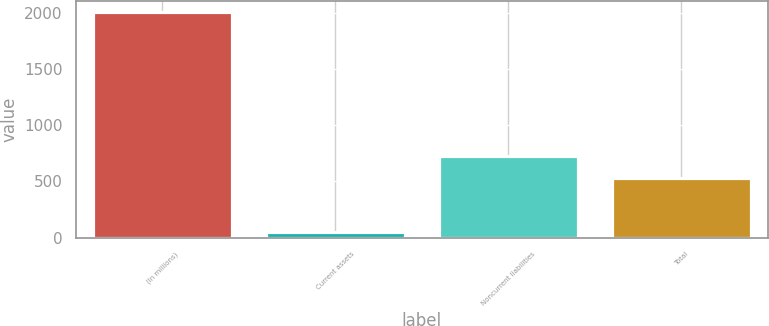<chart> <loc_0><loc_0><loc_500><loc_500><bar_chart><fcel>(In millions)<fcel>Current assets<fcel>Noncurrent liabilities<fcel>Total<nl><fcel>2009<fcel>46<fcel>730.3<fcel>534<nl></chart> 